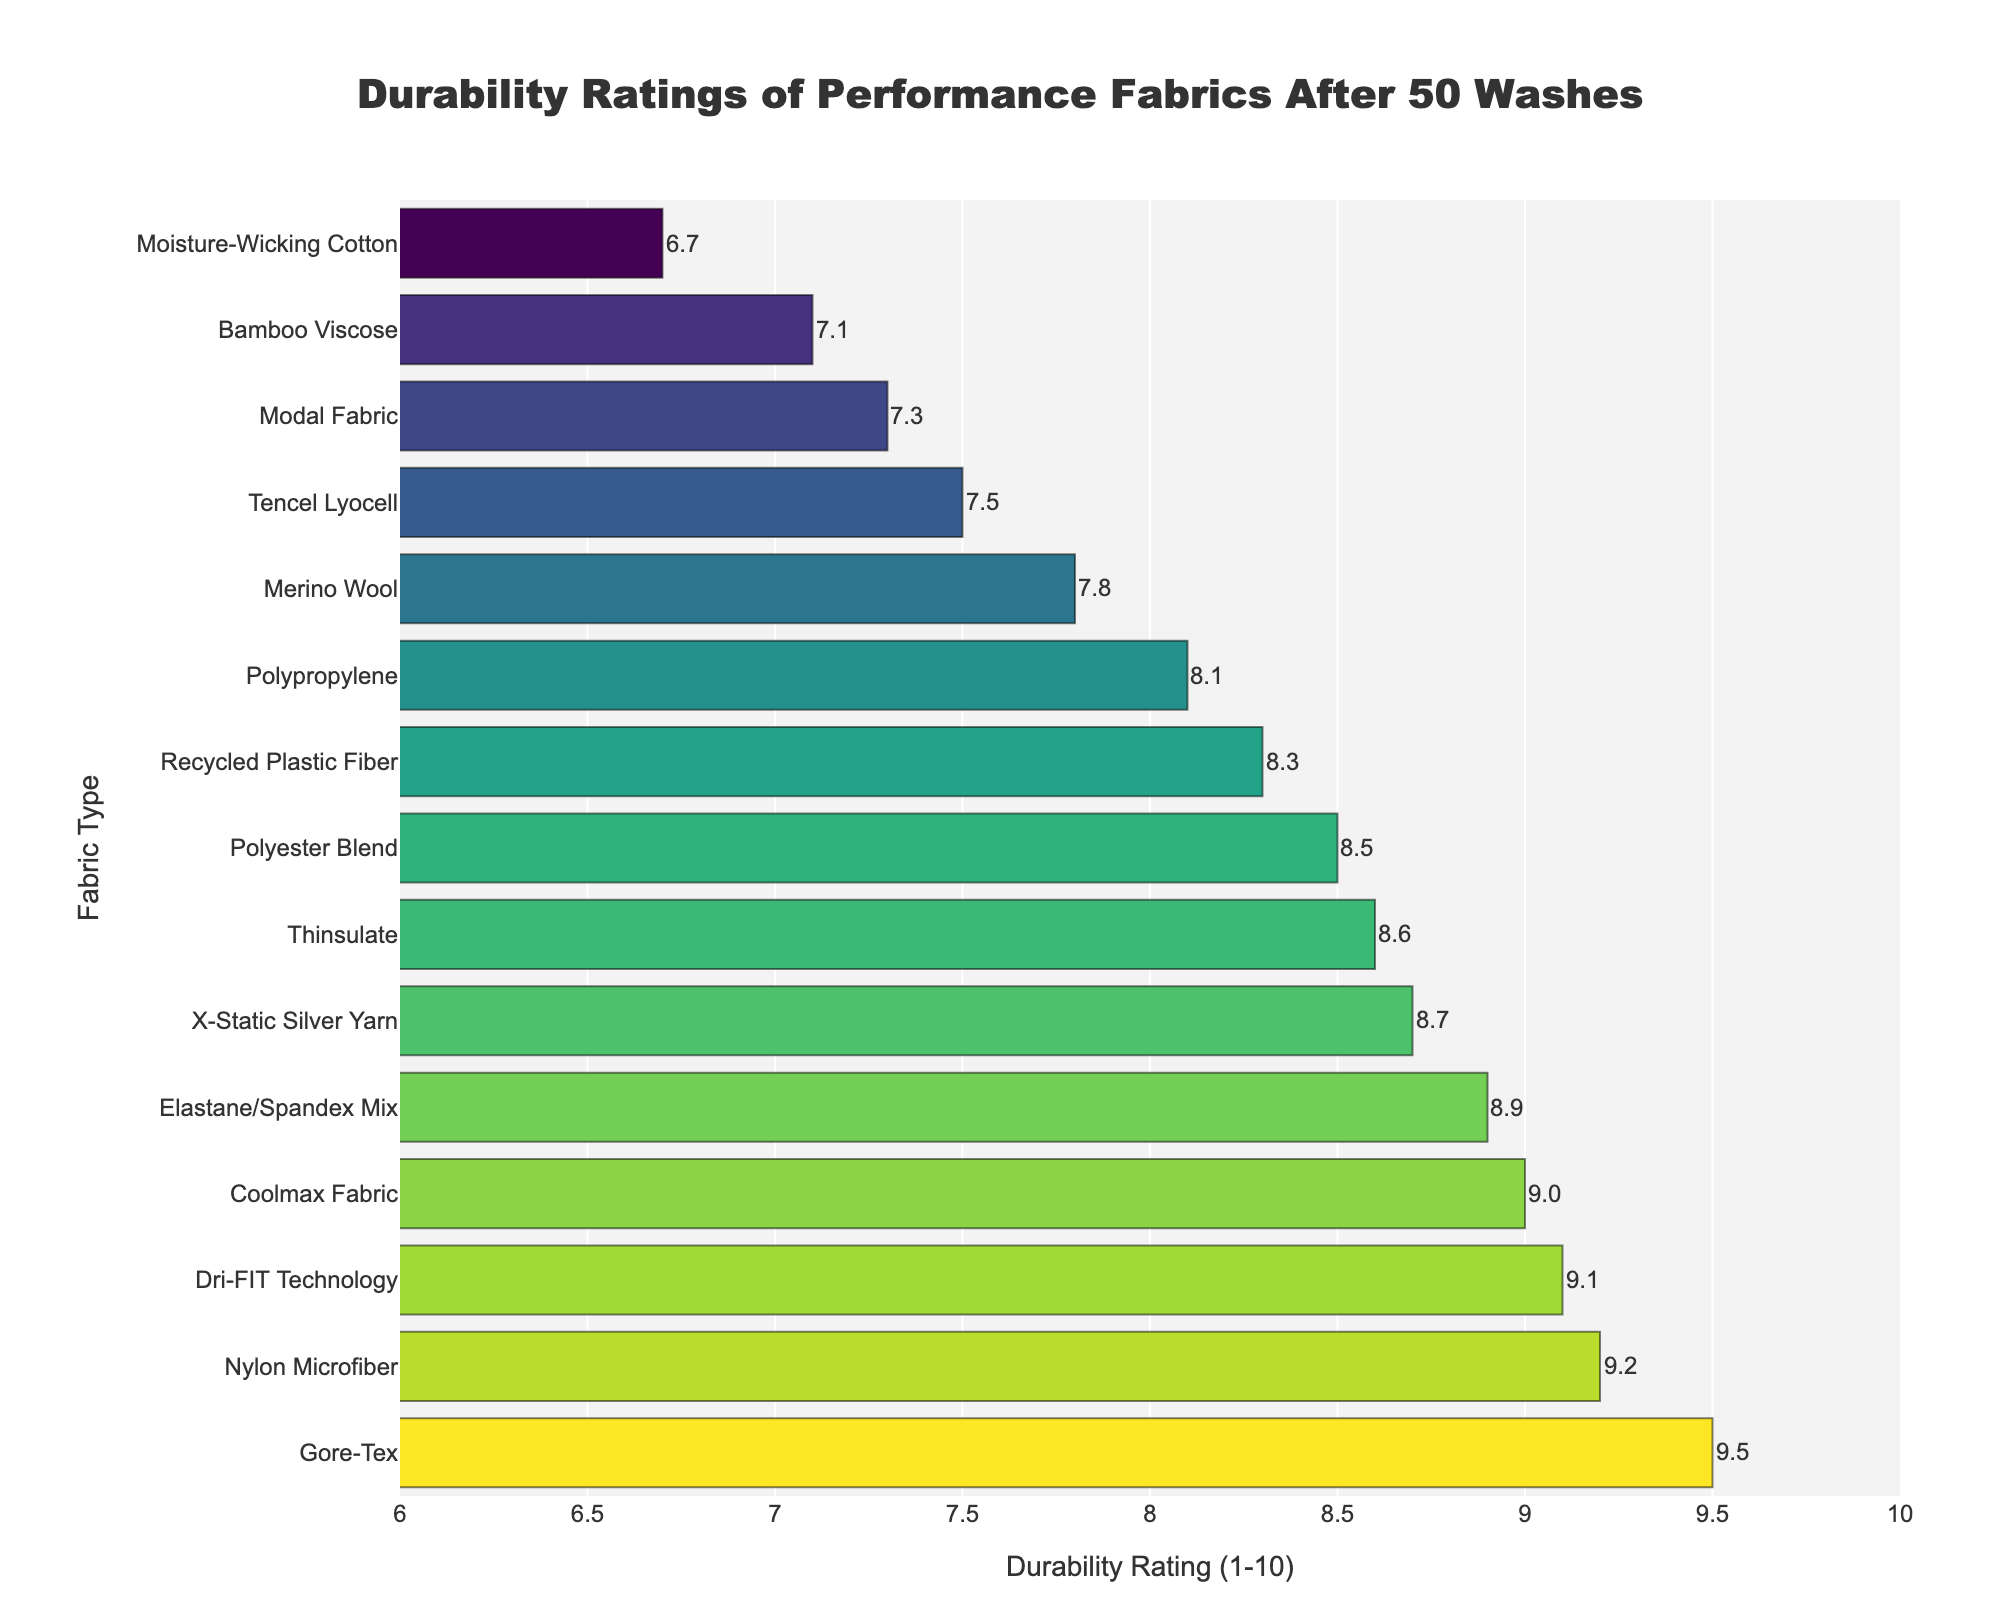Which fabric has the highest durability rating after 50 washes? The fabric with the highest durability rating will be the one with the longest bar extending furthest to the right in the figure.
Answer: Gore-Tex Which fabric has the lowest durability rating after 50 washes? The fabric with the lowest durability rating will be represented by the shortest bar extending the least to the right in the figure.
Answer: Moisture-Wicking Cotton How many fabrics have a durability rating of 9 or above after 50 washes? Count the number of bars that extend to a rating of 9.0 or higher.
Answer: 5 What is the sum of the durability ratings of Dri-FIT Technology and Coolmax Fabric after 50 washes? Find the ratings of Dri-FIT Technology and Coolmax Fabric from the figure and sum them up: Dri-FIT Technology = 9.1, Coolmax Fabric = 9.0, so the total is 9.1 + 9.0 = 18.1
Answer: 18.1 Which fabric has a higher durability rating: X-Static Silver Yarn or Thinsulate? Compare the lengths of the bars for X-Static Silver Yarn and Thinsulate to see which extends further to the right.
Answer: Thinsulate What is the average durability rating of the top five most durable fabrics after 50 washes? Identify the top five fabrics by their durability ratings: Gore-Tex (9.5), Nylon Microfiber (9.2), Dri-FIT Technology (9.1), Coolmax Fabric (9.0), Elastane/Spandex Mix (8.9). Calculate the average: (9.5 + 9.2 + 9.1 + 9.0 + 8.9) / 5 = 9.14
Answer: 9.14 Which fabrics have durability ratings between 8.0 and 9.0 after 50 washes? Identify the bars that fall within the range of 8.0 to 9.0. These are: Polyester Blend (8.5), Elastane/Spandex Mix (8.9), Recycled Plastic Fiber (8.3), Coolmax Fabric (9.0), X-Static Silver Yarn (8.7), Polypropylene (8.1), Thinsulate (8.6)
Answer: Polyester Blend, Elastane/Spandex Mix, Recycled Plastic Fiber, Coolmax Fabric, X-Static Silver Yarn, Polypropylene, Thinsulate How much greater is the durability rating of Gore-Tex compared to Merino Wool after 50 washes? Subtract the durability rating of Merino Wool from Gore-Tex: 9.5 - 7.8 = 1.7
Answer: 1.7 What's the median durability rating of all the fabrics after 50 washes? List all the ratings in ascending order and find the middle value. Ordered ratings: 6.7, 7.1, 7.3, 7.5, 7.8, 8.1, 8.3, 8.5, 8.6, 8.7, 8.9, 9.0, 9.1, 9.2, 9.5. The median value is the 8th one in this list: 8.3
Answer: 8.3 